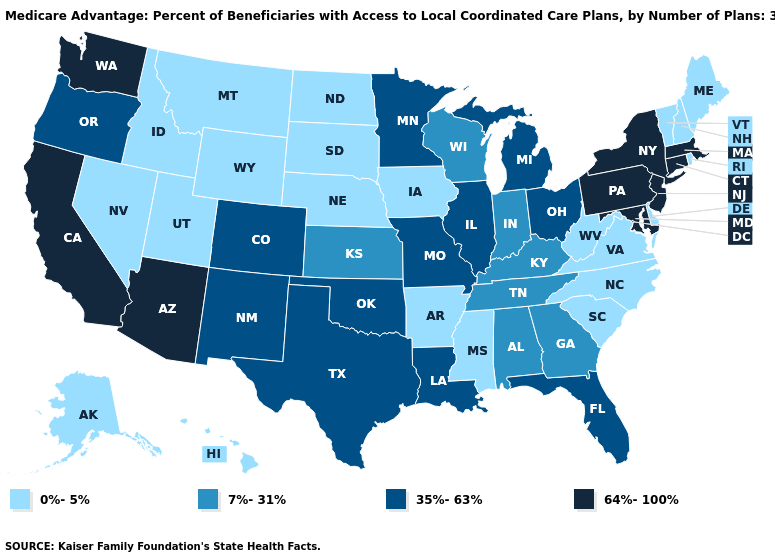Does Minnesota have the lowest value in the MidWest?
Answer briefly. No. Name the states that have a value in the range 35%-63%?
Concise answer only. Colorado, Florida, Illinois, Louisiana, Michigan, Minnesota, Missouri, New Mexico, Ohio, Oklahoma, Oregon, Texas. Does South Dakota have a lower value than North Carolina?
Be succinct. No. Name the states that have a value in the range 35%-63%?
Keep it brief. Colorado, Florida, Illinois, Louisiana, Michigan, Minnesota, Missouri, New Mexico, Ohio, Oklahoma, Oregon, Texas. Name the states that have a value in the range 7%-31%?
Give a very brief answer. Alabama, Georgia, Indiana, Kansas, Kentucky, Tennessee, Wisconsin. What is the lowest value in the South?
Be succinct. 0%-5%. What is the value of Alaska?
Keep it brief. 0%-5%. Which states have the highest value in the USA?
Quick response, please. Arizona, California, Connecticut, Massachusetts, Maryland, New Jersey, New York, Pennsylvania, Washington. Does Utah have a lower value than Oregon?
Write a very short answer. Yes. Among the states that border West Virginia , which have the highest value?
Keep it brief. Maryland, Pennsylvania. What is the highest value in the West ?
Answer briefly. 64%-100%. Does Kansas have the same value as Minnesota?
Short answer required. No. What is the value of New Hampshire?
Quick response, please. 0%-5%. Name the states that have a value in the range 64%-100%?
Keep it brief. Arizona, California, Connecticut, Massachusetts, Maryland, New Jersey, New York, Pennsylvania, Washington. 